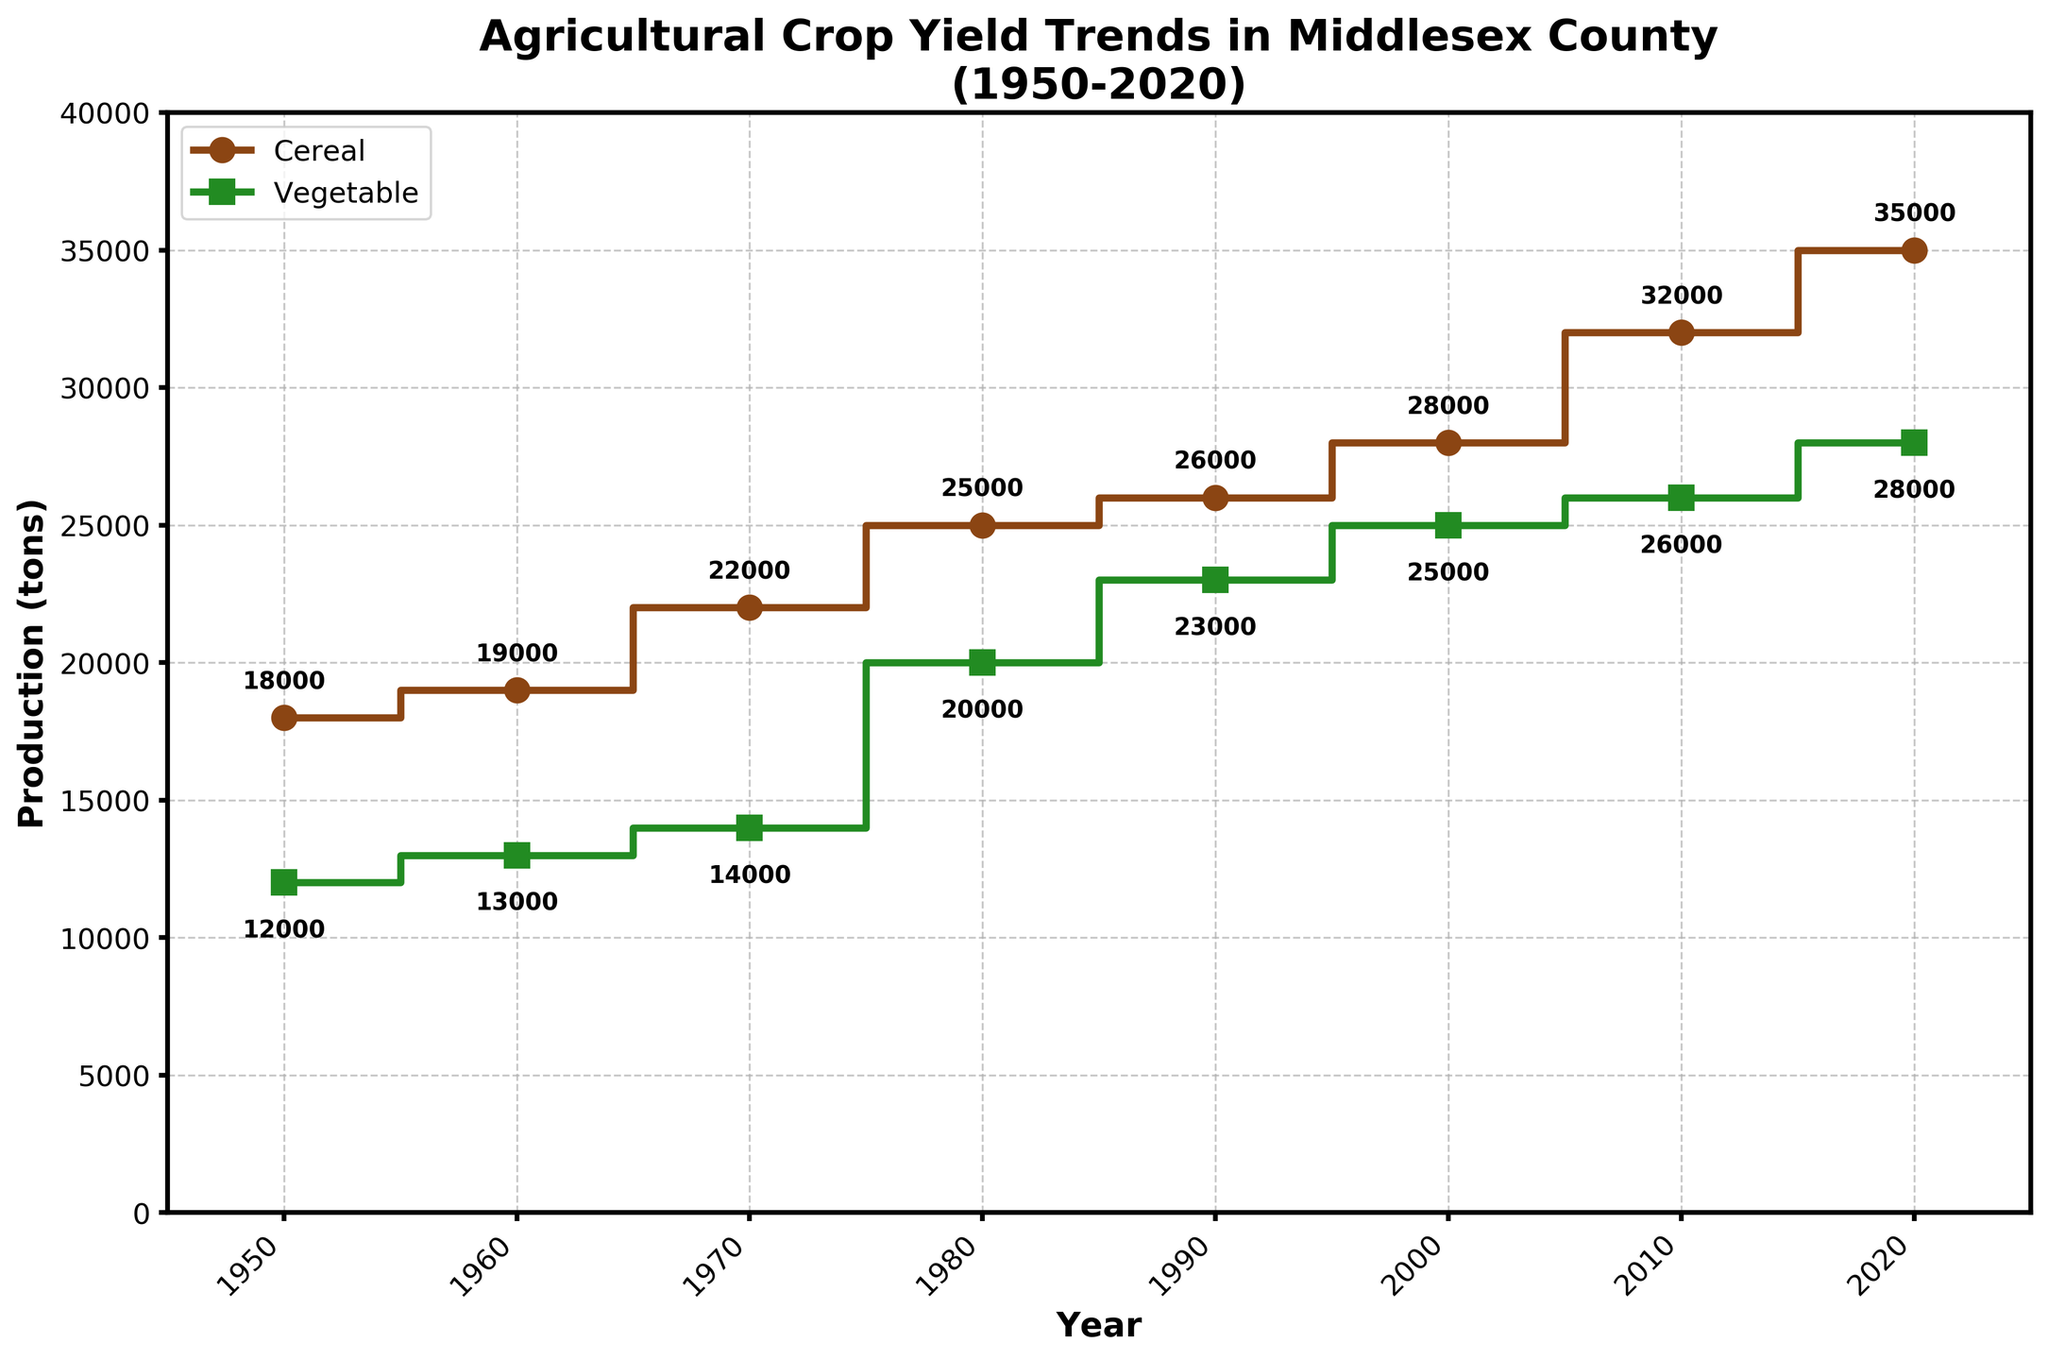What is the title of the plot? The title is displayed at the top center of the plot. It reads "Agricultural Crop Yield Trends in Middlesex County (1950-2020)."
Answer: Agricultural Crop Yield Trends in Middlesex County (1950-2020) How many years are represented on the plot? The x-axis of the plot shows the span of years. Count the number of unique years displayed.
Answer: 8 Which year had the highest cereal production? Look at the 'Cereal Production (tons)' data series and find the peak value. The annotation or the step line helps identify it.
Answer: 2020 By how much did vegetable production increase from 1950 to 2020? Subtract the vegetable production value in 1950 from the value in 2020: 28000 - 12000.
Answer: 16000 How does cereal production in 1980 compare to that in 2020? Observe the values for cereal production in 1980 and 2020. Cereal production in 2020 is shown as higher than in 1980. 35000 - 25000 gives the difference.
Answer: Increased by 10000 What was the cereal production in 1990? Locate the cereal production value for the year 1990, either from the step plot or the annotations that label the exact numbers.
Answer: 26000 What is the average vegetable production from 1950 to 2020? Add the vegetable production values for each year and divide by the number of years: (12000 + 13000 + 14000 + 20000 + 23000 + 25000 + 26000 + 28000)/8.
Answer: 20125 In what year was vegetable production equal to 20000 tons? Identify the step or annotation where vegetable production is marked as 20000 tons.
Answer: 1980 Compare the rate of increase in cereal and vegetable production from 2000 to 2010. Calculate the increase for each crop from 2000 to 2010 (cereal: 32000 - 28000, vegetable: 26000 - 25000) and compare the differences.
Answer: Cereal increased by 4000, vegetable increased by 1000 Which crop had a more substantial increase in production over the entire period? Calculate the total increase for both crops over the period: cereal (35000 - 18000), vegetable (28000 - 12000).
Answer: Cereal 